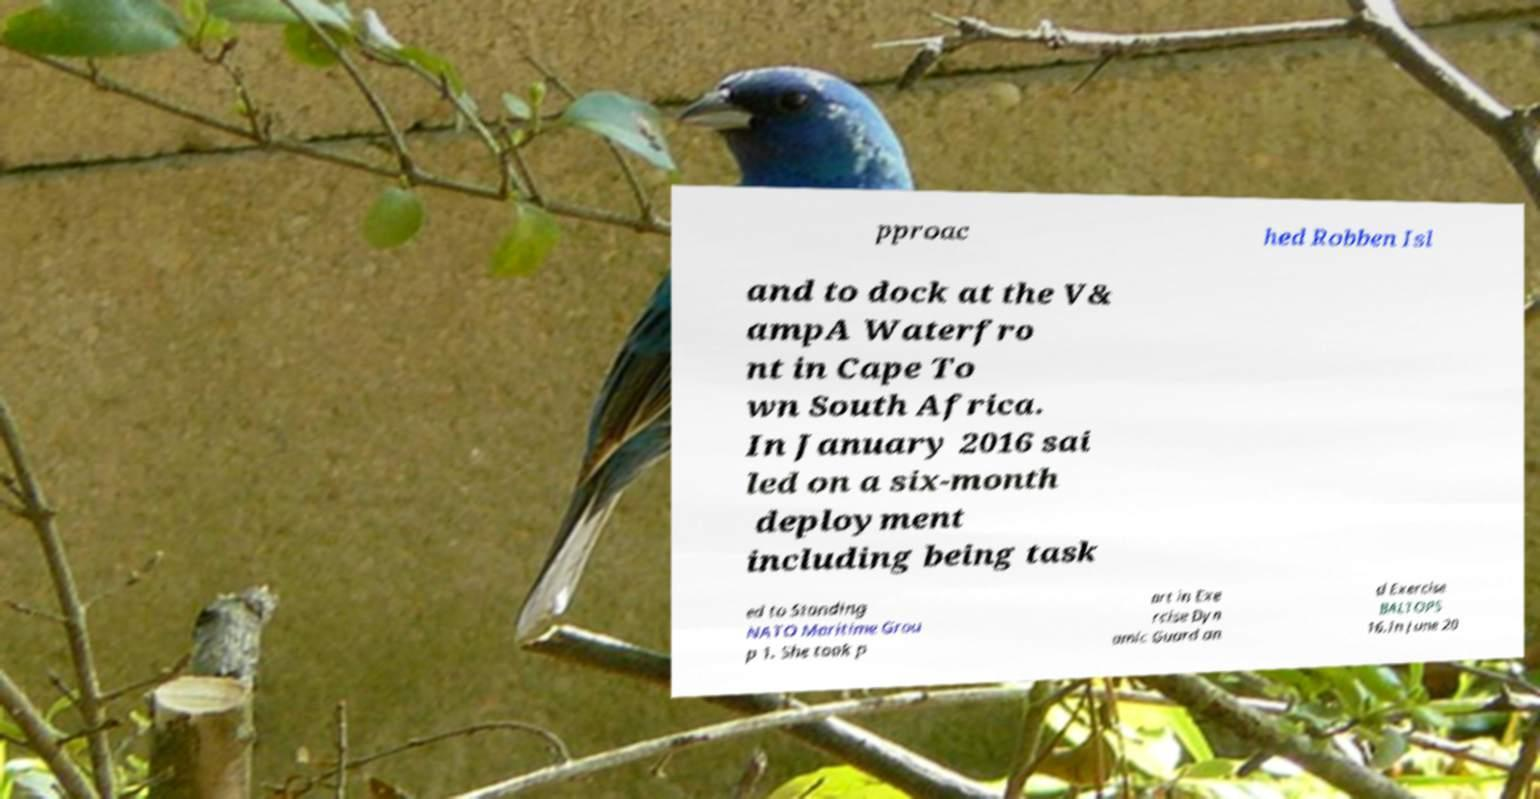Could you extract and type out the text from this image? pproac hed Robben Isl and to dock at the V& ampA Waterfro nt in Cape To wn South Africa. In January 2016 sai led on a six-month deployment including being task ed to Standing NATO Maritime Grou p 1. She took p art in Exe rcise Dyn amic Guard an d Exercise BALTOPS 16.In June 20 